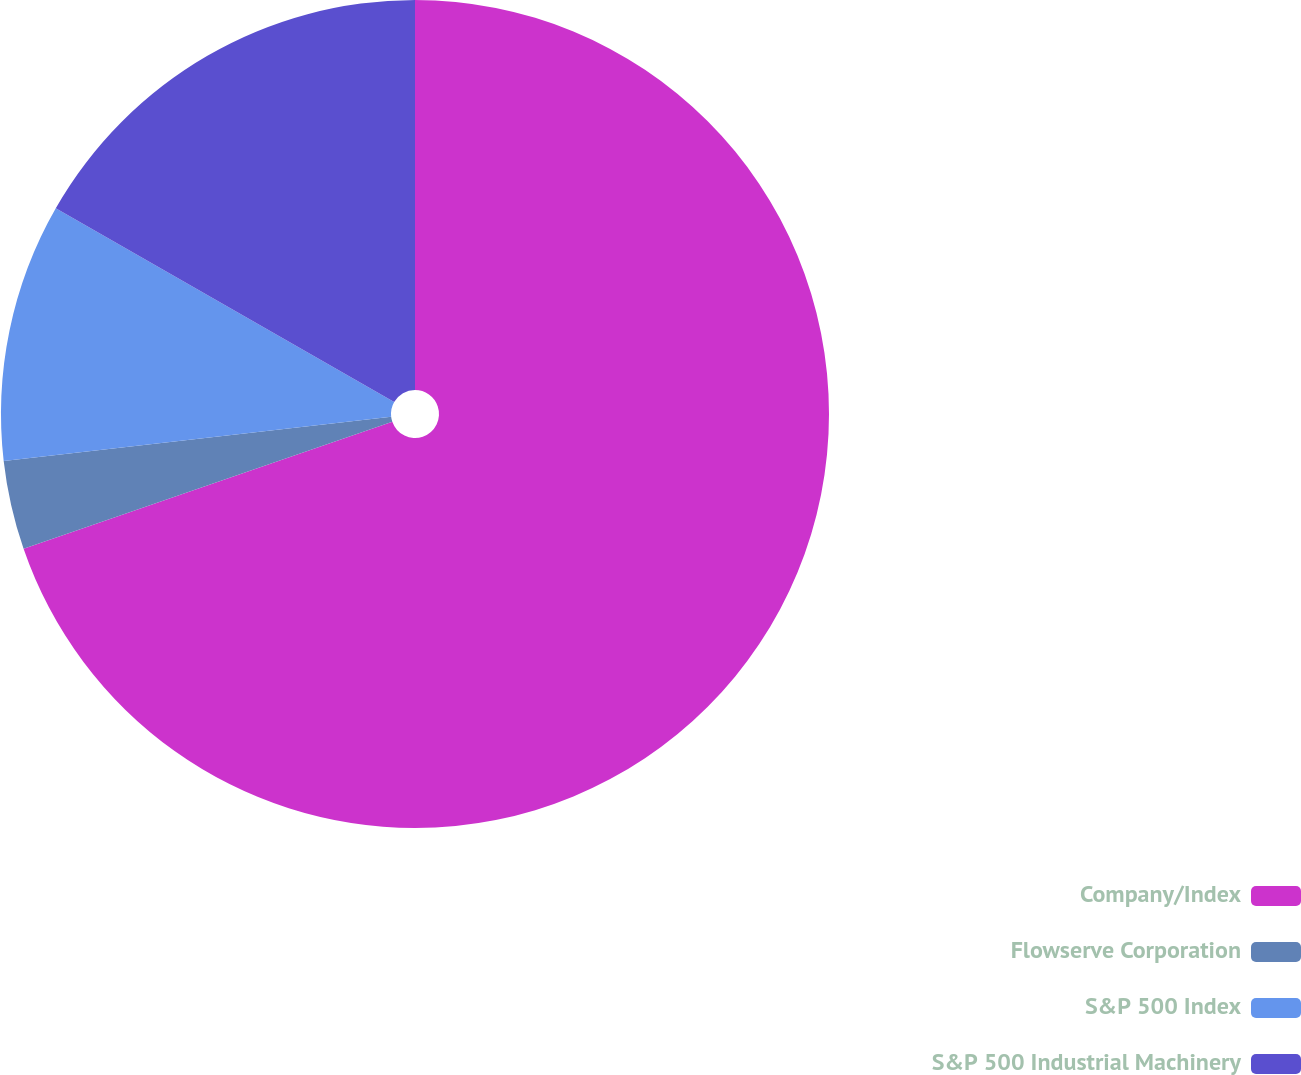Convert chart to OTSL. <chart><loc_0><loc_0><loc_500><loc_500><pie_chart><fcel>Company/Index<fcel>Flowserve Corporation<fcel>S&P 500 Index<fcel>S&P 500 Industrial Machinery<nl><fcel>69.72%<fcel>3.47%<fcel>10.09%<fcel>16.72%<nl></chart> 